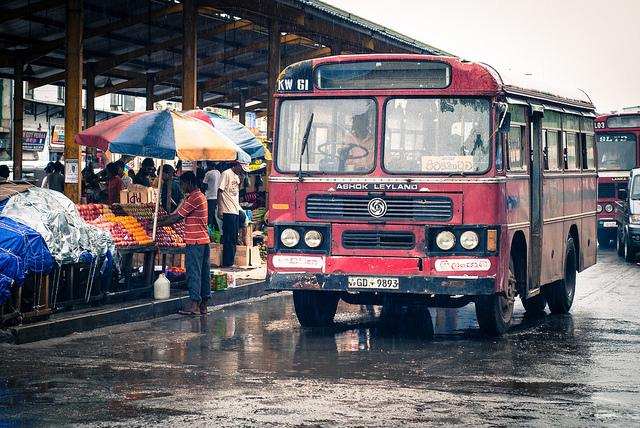What food can you buy as you get on the bus? fruit 